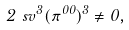Convert formula to latex. <formula><loc_0><loc_0><loc_500><loc_500>2 \ s v ^ { 3 } ( \pi ^ { 0 0 } ) ^ { 3 } \neq 0 ,</formula> 